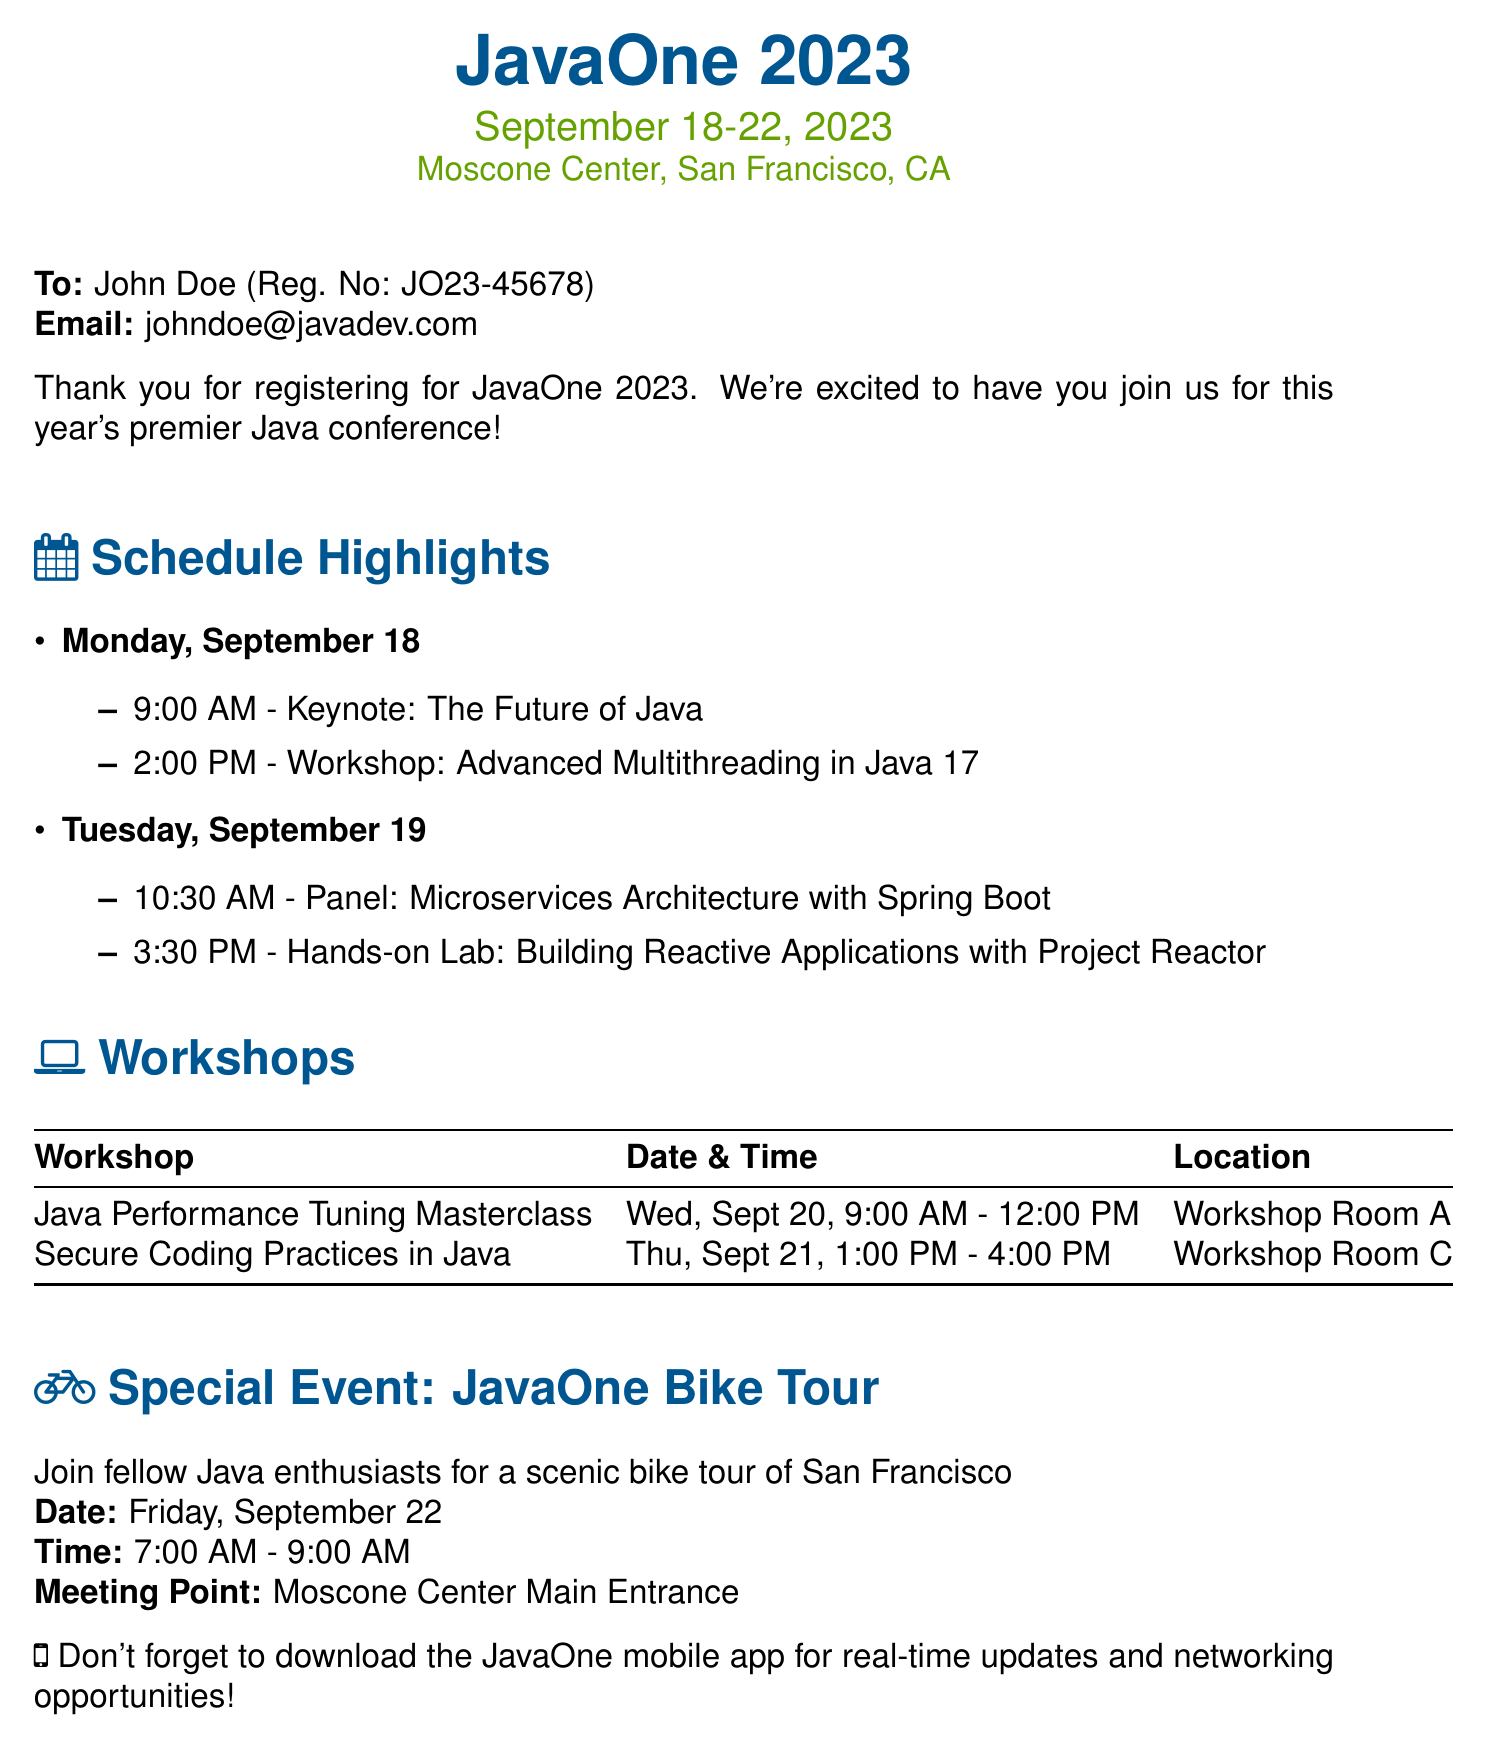What are the dates of the conference? The document states that the conference will take place from September 18-22, 2023.
Answer: September 18-22, 2023 Who is the registration confirmation addressed to? The document indicates that the confirmation is addressed to John Doe.
Answer: John Doe What is the title of the keynote session? The document lists "The Future of Java" as the keynote session title.
Answer: The Future of Java What workshop is scheduled for September 20? The document specifies "Java Performance Tuning Masterclass" as the workshop on that date.
Answer: Java Performance Tuning Masterclass What time is the JavaOne Bike Tour? According to the document, the JavaOne Bike Tour is scheduled for 7:00 AM - 9:00 AM.
Answer: 7:00 AM - 9:00 AM Which day features a panel on Microservices Architecture? The document mentions that the panel on Microservices Architecture occurs on Tuesday, September 19.
Answer: Tuesday, September 19 What is the location for the hands-on lab? The document states that the location for the hands-on lab is not explicitly mentioned but can be inferred to be at the Moscone Center.
Answer: Moscone Center What is the date for the workshop on Secure Coding Practices? The document specifies that this workshop is scheduled for Thursday, September 21.
Answer: Thursday, September 21 